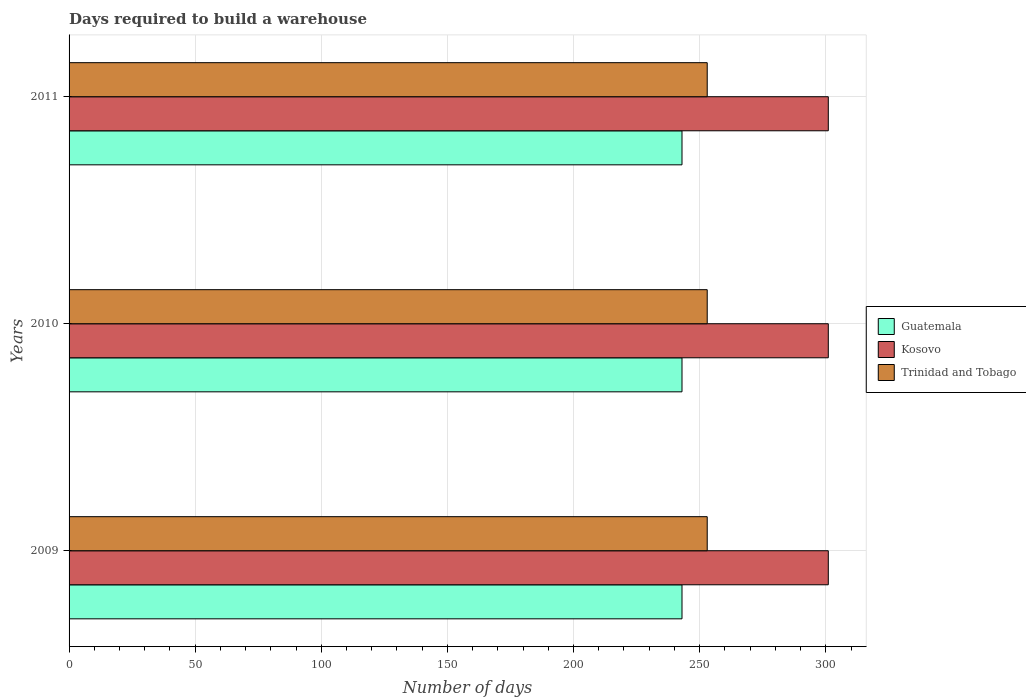How many different coloured bars are there?
Offer a very short reply. 3. How many groups of bars are there?
Your answer should be very brief. 3. How many bars are there on the 1st tick from the top?
Your answer should be very brief. 3. How many bars are there on the 3rd tick from the bottom?
Offer a terse response. 3. In how many cases, is the number of bars for a given year not equal to the number of legend labels?
Provide a short and direct response. 0. What is the days required to build a warehouse in in Guatemala in 2010?
Offer a terse response. 243. Across all years, what is the maximum days required to build a warehouse in in Trinidad and Tobago?
Offer a very short reply. 253. Across all years, what is the minimum days required to build a warehouse in in Trinidad and Tobago?
Offer a very short reply. 253. In which year was the days required to build a warehouse in in Trinidad and Tobago maximum?
Provide a short and direct response. 2009. In which year was the days required to build a warehouse in in Kosovo minimum?
Give a very brief answer. 2009. What is the total days required to build a warehouse in in Trinidad and Tobago in the graph?
Make the answer very short. 759. What is the difference between the days required to build a warehouse in in Guatemala in 2010 and that in 2011?
Give a very brief answer. 0. What is the difference between the days required to build a warehouse in in Kosovo in 2010 and the days required to build a warehouse in in Trinidad and Tobago in 2011?
Keep it short and to the point. 48. What is the average days required to build a warehouse in in Kosovo per year?
Your response must be concise. 301. Is the days required to build a warehouse in in Trinidad and Tobago in 2009 less than that in 2011?
Provide a succinct answer. No. What is the difference between the highest and the lowest days required to build a warehouse in in Guatemala?
Your response must be concise. 0. What does the 2nd bar from the top in 2010 represents?
Offer a very short reply. Kosovo. What does the 3rd bar from the bottom in 2009 represents?
Provide a short and direct response. Trinidad and Tobago. How many bars are there?
Your response must be concise. 9. Are all the bars in the graph horizontal?
Give a very brief answer. Yes. How many years are there in the graph?
Provide a short and direct response. 3. What is the difference between two consecutive major ticks on the X-axis?
Your answer should be compact. 50. How are the legend labels stacked?
Provide a short and direct response. Vertical. What is the title of the graph?
Your answer should be compact. Days required to build a warehouse. Does "Armenia" appear as one of the legend labels in the graph?
Ensure brevity in your answer.  No. What is the label or title of the X-axis?
Offer a terse response. Number of days. What is the label or title of the Y-axis?
Give a very brief answer. Years. What is the Number of days in Guatemala in 2009?
Ensure brevity in your answer.  243. What is the Number of days in Kosovo in 2009?
Offer a very short reply. 301. What is the Number of days in Trinidad and Tobago in 2009?
Ensure brevity in your answer.  253. What is the Number of days in Guatemala in 2010?
Give a very brief answer. 243. What is the Number of days of Kosovo in 2010?
Offer a very short reply. 301. What is the Number of days of Trinidad and Tobago in 2010?
Provide a succinct answer. 253. What is the Number of days of Guatemala in 2011?
Ensure brevity in your answer.  243. What is the Number of days in Kosovo in 2011?
Your response must be concise. 301. What is the Number of days in Trinidad and Tobago in 2011?
Ensure brevity in your answer.  253. Across all years, what is the maximum Number of days of Guatemala?
Make the answer very short. 243. Across all years, what is the maximum Number of days of Kosovo?
Your answer should be compact. 301. Across all years, what is the maximum Number of days of Trinidad and Tobago?
Give a very brief answer. 253. Across all years, what is the minimum Number of days in Guatemala?
Offer a very short reply. 243. Across all years, what is the minimum Number of days of Kosovo?
Provide a short and direct response. 301. Across all years, what is the minimum Number of days of Trinidad and Tobago?
Ensure brevity in your answer.  253. What is the total Number of days in Guatemala in the graph?
Provide a succinct answer. 729. What is the total Number of days in Kosovo in the graph?
Make the answer very short. 903. What is the total Number of days in Trinidad and Tobago in the graph?
Offer a very short reply. 759. What is the difference between the Number of days in Kosovo in 2009 and that in 2010?
Provide a short and direct response. 0. What is the difference between the Number of days of Trinidad and Tobago in 2009 and that in 2010?
Your answer should be compact. 0. What is the difference between the Number of days of Kosovo in 2010 and that in 2011?
Provide a short and direct response. 0. What is the difference between the Number of days of Guatemala in 2009 and the Number of days of Kosovo in 2010?
Ensure brevity in your answer.  -58. What is the difference between the Number of days in Guatemala in 2009 and the Number of days in Trinidad and Tobago in 2010?
Your response must be concise. -10. What is the difference between the Number of days of Guatemala in 2009 and the Number of days of Kosovo in 2011?
Make the answer very short. -58. What is the difference between the Number of days of Guatemala in 2010 and the Number of days of Kosovo in 2011?
Make the answer very short. -58. What is the difference between the Number of days of Guatemala in 2010 and the Number of days of Trinidad and Tobago in 2011?
Your response must be concise. -10. What is the average Number of days in Guatemala per year?
Your answer should be compact. 243. What is the average Number of days in Kosovo per year?
Give a very brief answer. 301. What is the average Number of days in Trinidad and Tobago per year?
Your answer should be compact. 253. In the year 2009, what is the difference between the Number of days of Guatemala and Number of days of Kosovo?
Provide a succinct answer. -58. In the year 2010, what is the difference between the Number of days of Guatemala and Number of days of Kosovo?
Provide a succinct answer. -58. In the year 2010, what is the difference between the Number of days of Kosovo and Number of days of Trinidad and Tobago?
Make the answer very short. 48. In the year 2011, what is the difference between the Number of days of Guatemala and Number of days of Kosovo?
Give a very brief answer. -58. In the year 2011, what is the difference between the Number of days in Kosovo and Number of days in Trinidad and Tobago?
Give a very brief answer. 48. What is the ratio of the Number of days in Kosovo in 2009 to that in 2010?
Give a very brief answer. 1. What is the ratio of the Number of days of Guatemala in 2009 to that in 2011?
Keep it short and to the point. 1. What is the ratio of the Number of days of Trinidad and Tobago in 2009 to that in 2011?
Ensure brevity in your answer.  1. What is the difference between the highest and the second highest Number of days of Guatemala?
Your answer should be compact. 0. What is the difference between the highest and the lowest Number of days in Kosovo?
Your response must be concise. 0. What is the difference between the highest and the lowest Number of days in Trinidad and Tobago?
Offer a very short reply. 0. 